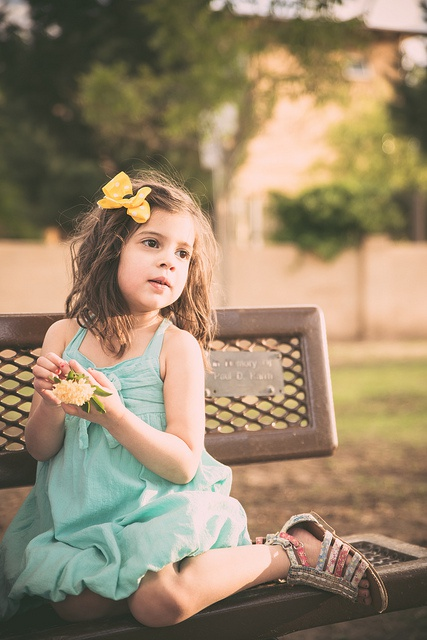Describe the objects in this image and their specific colors. I can see people in gray, lightgray, and tan tones and bench in gray, black, and tan tones in this image. 